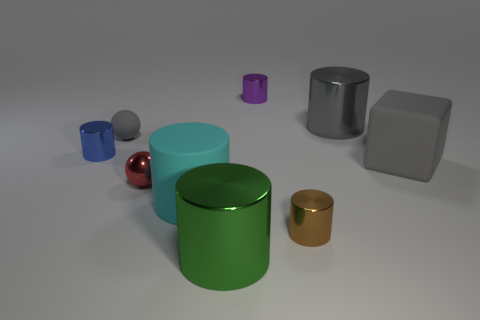Do the gray rubber thing left of the green metal thing and the red object have the same size? Upon closer inspection of the objects in the image, the gray rubber item to the left of the green metal cylinder appears to be slightly smaller than the red sphere. The gray object has more uniform dimensions, while the red sphere's distinct shape and reflective surface may give the impression that they are the same size when in fact there is a subtle difference. 